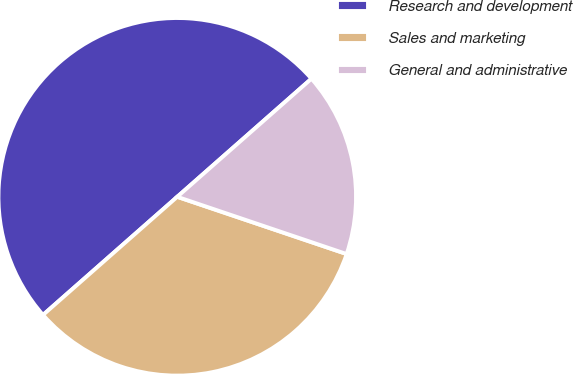<chart> <loc_0><loc_0><loc_500><loc_500><pie_chart><fcel>Research and development<fcel>Sales and marketing<fcel>General and administrative<nl><fcel>50.0%<fcel>33.33%<fcel>16.67%<nl></chart> 